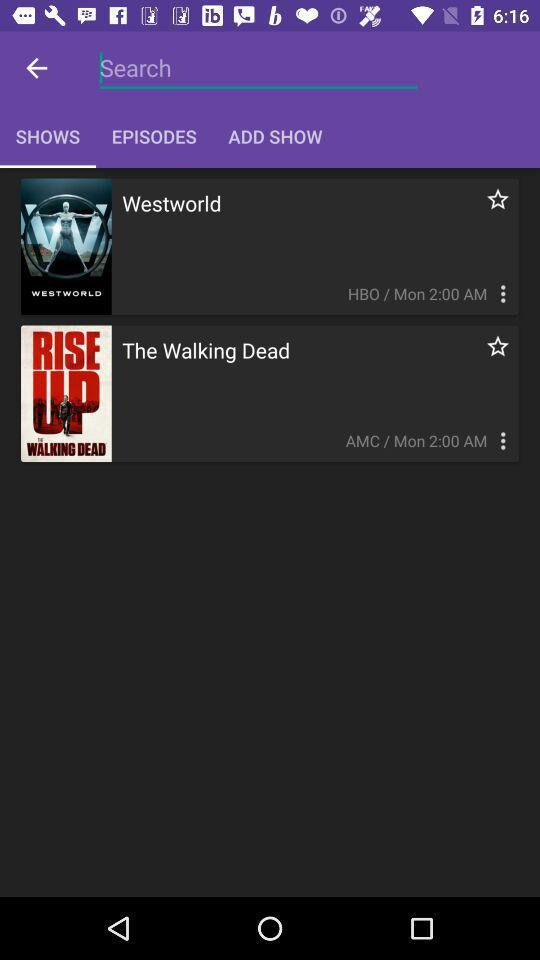What show is broadcast on the AMC channel? The show is "The Walking Dead". 